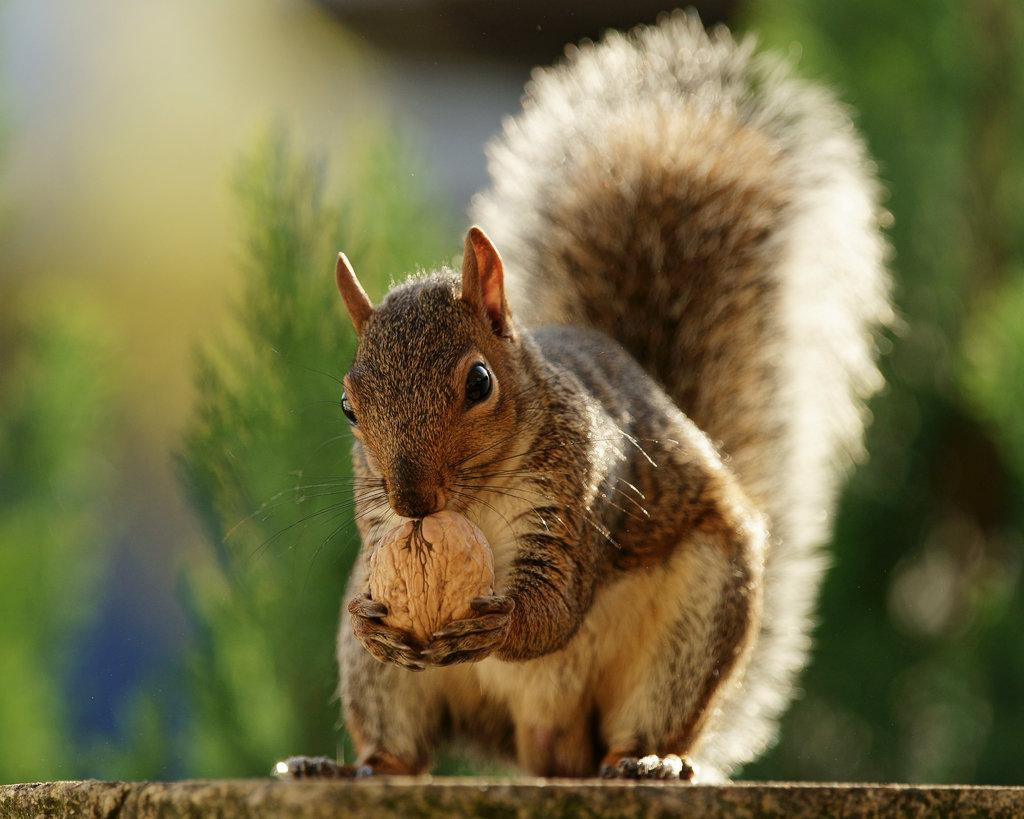What animal is present in the image? There is a squirrel in the image. What is the squirrel holding in its hands? The squirrel is holding a nut. Can you describe the background of the image? The background of the squirrel is blurred. What type of plate is the squirrel using to hold the nut? There is no plate present in the image; the squirrel is holding the nut directly. 